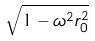<formula> <loc_0><loc_0><loc_500><loc_500>\sqrt { 1 - \omega ^ { 2 } r _ { 0 } ^ { 2 } }</formula> 